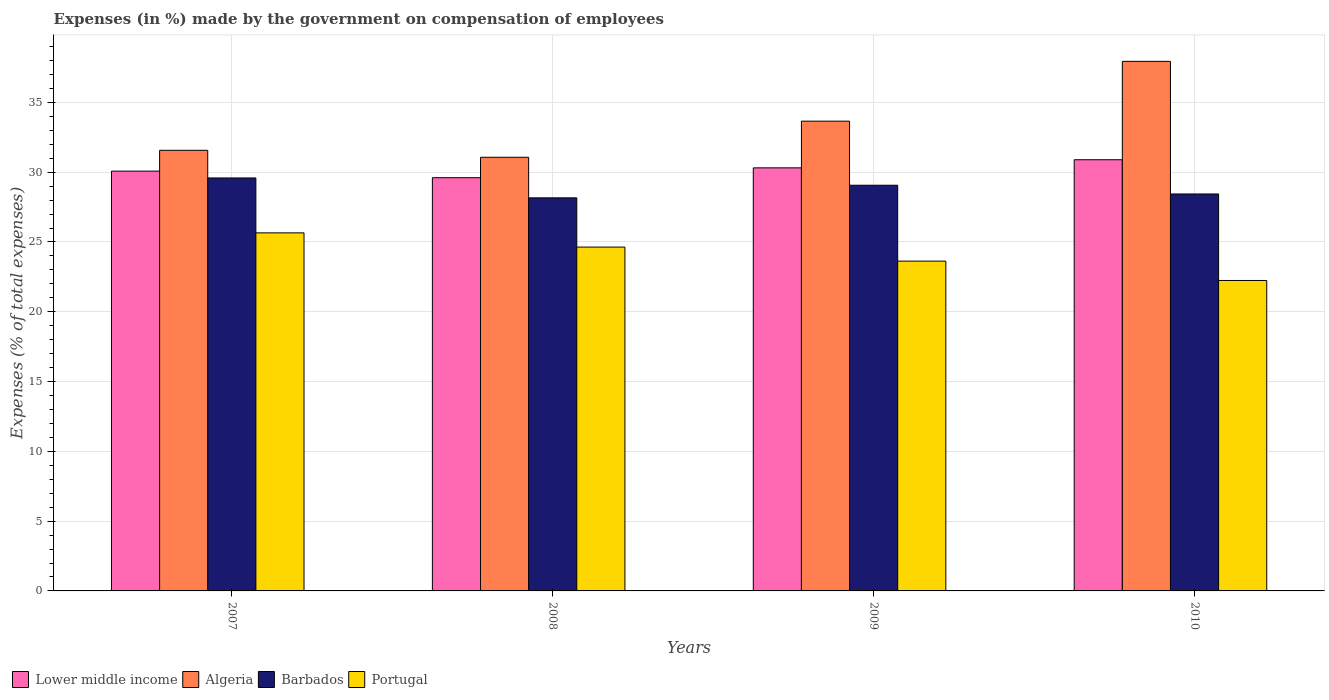Are the number of bars per tick equal to the number of legend labels?
Offer a very short reply. Yes. How many bars are there on the 2nd tick from the right?
Give a very brief answer. 4. What is the label of the 2nd group of bars from the left?
Ensure brevity in your answer.  2008. What is the percentage of expenses made by the government on compensation of employees in Barbados in 2008?
Your answer should be very brief. 28.16. Across all years, what is the maximum percentage of expenses made by the government on compensation of employees in Lower middle income?
Give a very brief answer. 30.89. Across all years, what is the minimum percentage of expenses made by the government on compensation of employees in Lower middle income?
Give a very brief answer. 29.6. What is the total percentage of expenses made by the government on compensation of employees in Algeria in the graph?
Your answer should be compact. 134.23. What is the difference between the percentage of expenses made by the government on compensation of employees in Lower middle income in 2008 and that in 2010?
Offer a very short reply. -1.29. What is the difference between the percentage of expenses made by the government on compensation of employees in Algeria in 2010 and the percentage of expenses made by the government on compensation of employees in Lower middle income in 2009?
Provide a succinct answer. 7.63. What is the average percentage of expenses made by the government on compensation of employees in Lower middle income per year?
Provide a succinct answer. 30.22. In the year 2007, what is the difference between the percentage of expenses made by the government on compensation of employees in Barbados and percentage of expenses made by the government on compensation of employees in Lower middle income?
Your response must be concise. -0.49. In how many years, is the percentage of expenses made by the government on compensation of employees in Algeria greater than 36 %?
Keep it short and to the point. 1. What is the ratio of the percentage of expenses made by the government on compensation of employees in Portugal in 2008 to that in 2009?
Keep it short and to the point. 1.04. Is the difference between the percentage of expenses made by the government on compensation of employees in Barbados in 2007 and 2010 greater than the difference between the percentage of expenses made by the government on compensation of employees in Lower middle income in 2007 and 2010?
Offer a terse response. Yes. What is the difference between the highest and the second highest percentage of expenses made by the government on compensation of employees in Algeria?
Your answer should be very brief. 4.28. What is the difference between the highest and the lowest percentage of expenses made by the government on compensation of employees in Lower middle income?
Offer a very short reply. 1.29. Is it the case that in every year, the sum of the percentage of expenses made by the government on compensation of employees in Algeria and percentage of expenses made by the government on compensation of employees in Lower middle income is greater than the sum of percentage of expenses made by the government on compensation of employees in Portugal and percentage of expenses made by the government on compensation of employees in Barbados?
Your answer should be very brief. No. What does the 3rd bar from the left in 2007 represents?
Offer a terse response. Barbados. What does the 2nd bar from the right in 2007 represents?
Your answer should be compact. Barbados. Are all the bars in the graph horizontal?
Make the answer very short. No. How many years are there in the graph?
Provide a short and direct response. 4. What is the difference between two consecutive major ticks on the Y-axis?
Your response must be concise. 5. Are the values on the major ticks of Y-axis written in scientific E-notation?
Your answer should be compact. No. Where does the legend appear in the graph?
Provide a short and direct response. Bottom left. How many legend labels are there?
Provide a succinct answer. 4. What is the title of the graph?
Offer a very short reply. Expenses (in %) made by the government on compensation of employees. What is the label or title of the Y-axis?
Your response must be concise. Expenses (% of total expenses). What is the Expenses (% of total expenses) in Lower middle income in 2007?
Ensure brevity in your answer.  30.08. What is the Expenses (% of total expenses) of Algeria in 2007?
Your answer should be very brief. 31.57. What is the Expenses (% of total expenses) in Barbados in 2007?
Keep it short and to the point. 29.59. What is the Expenses (% of total expenses) of Portugal in 2007?
Your answer should be compact. 25.65. What is the Expenses (% of total expenses) in Lower middle income in 2008?
Offer a very short reply. 29.6. What is the Expenses (% of total expenses) in Algeria in 2008?
Give a very brief answer. 31.07. What is the Expenses (% of total expenses) in Barbados in 2008?
Your answer should be compact. 28.16. What is the Expenses (% of total expenses) in Portugal in 2008?
Provide a succinct answer. 24.63. What is the Expenses (% of total expenses) of Lower middle income in 2009?
Keep it short and to the point. 30.31. What is the Expenses (% of total expenses) in Algeria in 2009?
Offer a terse response. 33.66. What is the Expenses (% of total expenses) of Barbados in 2009?
Provide a short and direct response. 29.06. What is the Expenses (% of total expenses) in Portugal in 2009?
Your answer should be compact. 23.63. What is the Expenses (% of total expenses) in Lower middle income in 2010?
Provide a short and direct response. 30.89. What is the Expenses (% of total expenses) of Algeria in 2010?
Your answer should be compact. 37.94. What is the Expenses (% of total expenses) of Barbados in 2010?
Keep it short and to the point. 28.44. What is the Expenses (% of total expenses) of Portugal in 2010?
Offer a very short reply. 22.24. Across all years, what is the maximum Expenses (% of total expenses) of Lower middle income?
Keep it short and to the point. 30.89. Across all years, what is the maximum Expenses (% of total expenses) of Algeria?
Provide a short and direct response. 37.94. Across all years, what is the maximum Expenses (% of total expenses) in Barbados?
Make the answer very short. 29.59. Across all years, what is the maximum Expenses (% of total expenses) of Portugal?
Give a very brief answer. 25.65. Across all years, what is the minimum Expenses (% of total expenses) of Lower middle income?
Your answer should be compact. 29.6. Across all years, what is the minimum Expenses (% of total expenses) of Algeria?
Make the answer very short. 31.07. Across all years, what is the minimum Expenses (% of total expenses) in Barbados?
Give a very brief answer. 28.16. Across all years, what is the minimum Expenses (% of total expenses) in Portugal?
Keep it short and to the point. 22.24. What is the total Expenses (% of total expenses) of Lower middle income in the graph?
Provide a short and direct response. 120.88. What is the total Expenses (% of total expenses) of Algeria in the graph?
Make the answer very short. 134.23. What is the total Expenses (% of total expenses) of Barbados in the graph?
Keep it short and to the point. 115.25. What is the total Expenses (% of total expenses) in Portugal in the graph?
Your answer should be very brief. 96.15. What is the difference between the Expenses (% of total expenses) of Lower middle income in 2007 and that in 2008?
Keep it short and to the point. 0.47. What is the difference between the Expenses (% of total expenses) of Algeria in 2007 and that in 2008?
Provide a succinct answer. 0.5. What is the difference between the Expenses (% of total expenses) of Barbados in 2007 and that in 2008?
Provide a succinct answer. 1.43. What is the difference between the Expenses (% of total expenses) of Portugal in 2007 and that in 2008?
Make the answer very short. 1.02. What is the difference between the Expenses (% of total expenses) in Lower middle income in 2007 and that in 2009?
Provide a short and direct response. -0.23. What is the difference between the Expenses (% of total expenses) of Algeria in 2007 and that in 2009?
Your answer should be compact. -2.09. What is the difference between the Expenses (% of total expenses) of Barbados in 2007 and that in 2009?
Provide a succinct answer. 0.52. What is the difference between the Expenses (% of total expenses) of Portugal in 2007 and that in 2009?
Make the answer very short. 2.02. What is the difference between the Expenses (% of total expenses) in Lower middle income in 2007 and that in 2010?
Offer a very short reply. -0.82. What is the difference between the Expenses (% of total expenses) of Algeria in 2007 and that in 2010?
Provide a succinct answer. -6.37. What is the difference between the Expenses (% of total expenses) of Barbados in 2007 and that in 2010?
Provide a succinct answer. 1.15. What is the difference between the Expenses (% of total expenses) of Portugal in 2007 and that in 2010?
Your answer should be compact. 3.41. What is the difference between the Expenses (% of total expenses) in Lower middle income in 2008 and that in 2009?
Your answer should be compact. -0.71. What is the difference between the Expenses (% of total expenses) in Algeria in 2008 and that in 2009?
Make the answer very short. -2.59. What is the difference between the Expenses (% of total expenses) of Barbados in 2008 and that in 2009?
Make the answer very short. -0.9. What is the difference between the Expenses (% of total expenses) of Portugal in 2008 and that in 2009?
Your response must be concise. 1. What is the difference between the Expenses (% of total expenses) of Lower middle income in 2008 and that in 2010?
Give a very brief answer. -1.29. What is the difference between the Expenses (% of total expenses) in Algeria in 2008 and that in 2010?
Your response must be concise. -6.87. What is the difference between the Expenses (% of total expenses) in Barbados in 2008 and that in 2010?
Offer a terse response. -0.28. What is the difference between the Expenses (% of total expenses) of Portugal in 2008 and that in 2010?
Offer a terse response. 2.39. What is the difference between the Expenses (% of total expenses) in Lower middle income in 2009 and that in 2010?
Give a very brief answer. -0.58. What is the difference between the Expenses (% of total expenses) in Algeria in 2009 and that in 2010?
Your answer should be very brief. -4.28. What is the difference between the Expenses (% of total expenses) in Barbados in 2009 and that in 2010?
Your response must be concise. 0.63. What is the difference between the Expenses (% of total expenses) of Portugal in 2009 and that in 2010?
Provide a short and direct response. 1.39. What is the difference between the Expenses (% of total expenses) in Lower middle income in 2007 and the Expenses (% of total expenses) in Algeria in 2008?
Your answer should be compact. -0.99. What is the difference between the Expenses (% of total expenses) in Lower middle income in 2007 and the Expenses (% of total expenses) in Barbados in 2008?
Ensure brevity in your answer.  1.92. What is the difference between the Expenses (% of total expenses) of Lower middle income in 2007 and the Expenses (% of total expenses) of Portugal in 2008?
Keep it short and to the point. 5.44. What is the difference between the Expenses (% of total expenses) in Algeria in 2007 and the Expenses (% of total expenses) in Barbados in 2008?
Make the answer very short. 3.41. What is the difference between the Expenses (% of total expenses) in Algeria in 2007 and the Expenses (% of total expenses) in Portugal in 2008?
Keep it short and to the point. 6.93. What is the difference between the Expenses (% of total expenses) of Barbados in 2007 and the Expenses (% of total expenses) of Portugal in 2008?
Your answer should be very brief. 4.95. What is the difference between the Expenses (% of total expenses) in Lower middle income in 2007 and the Expenses (% of total expenses) in Algeria in 2009?
Your answer should be compact. -3.58. What is the difference between the Expenses (% of total expenses) in Lower middle income in 2007 and the Expenses (% of total expenses) in Barbados in 2009?
Offer a terse response. 1.01. What is the difference between the Expenses (% of total expenses) in Lower middle income in 2007 and the Expenses (% of total expenses) in Portugal in 2009?
Provide a succinct answer. 6.45. What is the difference between the Expenses (% of total expenses) of Algeria in 2007 and the Expenses (% of total expenses) of Barbados in 2009?
Ensure brevity in your answer.  2.5. What is the difference between the Expenses (% of total expenses) of Algeria in 2007 and the Expenses (% of total expenses) of Portugal in 2009?
Offer a very short reply. 7.94. What is the difference between the Expenses (% of total expenses) of Barbados in 2007 and the Expenses (% of total expenses) of Portugal in 2009?
Provide a succinct answer. 5.96. What is the difference between the Expenses (% of total expenses) of Lower middle income in 2007 and the Expenses (% of total expenses) of Algeria in 2010?
Give a very brief answer. -7.86. What is the difference between the Expenses (% of total expenses) in Lower middle income in 2007 and the Expenses (% of total expenses) in Barbados in 2010?
Give a very brief answer. 1.64. What is the difference between the Expenses (% of total expenses) in Lower middle income in 2007 and the Expenses (% of total expenses) in Portugal in 2010?
Your response must be concise. 7.83. What is the difference between the Expenses (% of total expenses) of Algeria in 2007 and the Expenses (% of total expenses) of Barbados in 2010?
Your answer should be very brief. 3.13. What is the difference between the Expenses (% of total expenses) of Algeria in 2007 and the Expenses (% of total expenses) of Portugal in 2010?
Your answer should be very brief. 9.33. What is the difference between the Expenses (% of total expenses) of Barbados in 2007 and the Expenses (% of total expenses) of Portugal in 2010?
Offer a very short reply. 7.34. What is the difference between the Expenses (% of total expenses) in Lower middle income in 2008 and the Expenses (% of total expenses) in Algeria in 2009?
Make the answer very short. -4.05. What is the difference between the Expenses (% of total expenses) in Lower middle income in 2008 and the Expenses (% of total expenses) in Barbados in 2009?
Keep it short and to the point. 0.54. What is the difference between the Expenses (% of total expenses) of Lower middle income in 2008 and the Expenses (% of total expenses) of Portugal in 2009?
Your answer should be very brief. 5.98. What is the difference between the Expenses (% of total expenses) of Algeria in 2008 and the Expenses (% of total expenses) of Barbados in 2009?
Make the answer very short. 2. What is the difference between the Expenses (% of total expenses) of Algeria in 2008 and the Expenses (% of total expenses) of Portugal in 2009?
Offer a terse response. 7.44. What is the difference between the Expenses (% of total expenses) in Barbados in 2008 and the Expenses (% of total expenses) in Portugal in 2009?
Your response must be concise. 4.53. What is the difference between the Expenses (% of total expenses) in Lower middle income in 2008 and the Expenses (% of total expenses) in Algeria in 2010?
Your answer should be compact. -8.34. What is the difference between the Expenses (% of total expenses) in Lower middle income in 2008 and the Expenses (% of total expenses) in Barbados in 2010?
Give a very brief answer. 1.17. What is the difference between the Expenses (% of total expenses) of Lower middle income in 2008 and the Expenses (% of total expenses) of Portugal in 2010?
Offer a very short reply. 7.36. What is the difference between the Expenses (% of total expenses) of Algeria in 2008 and the Expenses (% of total expenses) of Barbados in 2010?
Your response must be concise. 2.63. What is the difference between the Expenses (% of total expenses) in Algeria in 2008 and the Expenses (% of total expenses) in Portugal in 2010?
Make the answer very short. 8.83. What is the difference between the Expenses (% of total expenses) of Barbados in 2008 and the Expenses (% of total expenses) of Portugal in 2010?
Offer a terse response. 5.92. What is the difference between the Expenses (% of total expenses) of Lower middle income in 2009 and the Expenses (% of total expenses) of Algeria in 2010?
Offer a very short reply. -7.63. What is the difference between the Expenses (% of total expenses) in Lower middle income in 2009 and the Expenses (% of total expenses) in Barbados in 2010?
Make the answer very short. 1.87. What is the difference between the Expenses (% of total expenses) in Lower middle income in 2009 and the Expenses (% of total expenses) in Portugal in 2010?
Give a very brief answer. 8.07. What is the difference between the Expenses (% of total expenses) of Algeria in 2009 and the Expenses (% of total expenses) of Barbados in 2010?
Your answer should be compact. 5.22. What is the difference between the Expenses (% of total expenses) in Algeria in 2009 and the Expenses (% of total expenses) in Portugal in 2010?
Offer a very short reply. 11.41. What is the difference between the Expenses (% of total expenses) in Barbados in 2009 and the Expenses (% of total expenses) in Portugal in 2010?
Give a very brief answer. 6.82. What is the average Expenses (% of total expenses) in Lower middle income per year?
Ensure brevity in your answer.  30.22. What is the average Expenses (% of total expenses) in Algeria per year?
Your answer should be compact. 33.56. What is the average Expenses (% of total expenses) in Barbados per year?
Provide a short and direct response. 28.81. What is the average Expenses (% of total expenses) in Portugal per year?
Keep it short and to the point. 24.04. In the year 2007, what is the difference between the Expenses (% of total expenses) in Lower middle income and Expenses (% of total expenses) in Algeria?
Offer a very short reply. -1.49. In the year 2007, what is the difference between the Expenses (% of total expenses) in Lower middle income and Expenses (% of total expenses) in Barbados?
Your answer should be very brief. 0.49. In the year 2007, what is the difference between the Expenses (% of total expenses) of Lower middle income and Expenses (% of total expenses) of Portugal?
Your answer should be compact. 4.42. In the year 2007, what is the difference between the Expenses (% of total expenses) of Algeria and Expenses (% of total expenses) of Barbados?
Provide a short and direct response. 1.98. In the year 2007, what is the difference between the Expenses (% of total expenses) in Algeria and Expenses (% of total expenses) in Portugal?
Give a very brief answer. 5.91. In the year 2007, what is the difference between the Expenses (% of total expenses) in Barbados and Expenses (% of total expenses) in Portugal?
Give a very brief answer. 3.93. In the year 2008, what is the difference between the Expenses (% of total expenses) in Lower middle income and Expenses (% of total expenses) in Algeria?
Provide a short and direct response. -1.46. In the year 2008, what is the difference between the Expenses (% of total expenses) of Lower middle income and Expenses (% of total expenses) of Barbados?
Provide a succinct answer. 1.44. In the year 2008, what is the difference between the Expenses (% of total expenses) of Lower middle income and Expenses (% of total expenses) of Portugal?
Make the answer very short. 4.97. In the year 2008, what is the difference between the Expenses (% of total expenses) of Algeria and Expenses (% of total expenses) of Barbados?
Keep it short and to the point. 2.91. In the year 2008, what is the difference between the Expenses (% of total expenses) in Algeria and Expenses (% of total expenses) in Portugal?
Offer a terse response. 6.43. In the year 2008, what is the difference between the Expenses (% of total expenses) of Barbados and Expenses (% of total expenses) of Portugal?
Your response must be concise. 3.53. In the year 2009, what is the difference between the Expenses (% of total expenses) in Lower middle income and Expenses (% of total expenses) in Algeria?
Provide a short and direct response. -3.35. In the year 2009, what is the difference between the Expenses (% of total expenses) in Lower middle income and Expenses (% of total expenses) in Barbados?
Keep it short and to the point. 1.25. In the year 2009, what is the difference between the Expenses (% of total expenses) of Lower middle income and Expenses (% of total expenses) of Portugal?
Offer a very short reply. 6.68. In the year 2009, what is the difference between the Expenses (% of total expenses) of Algeria and Expenses (% of total expenses) of Barbados?
Keep it short and to the point. 4.59. In the year 2009, what is the difference between the Expenses (% of total expenses) of Algeria and Expenses (% of total expenses) of Portugal?
Make the answer very short. 10.03. In the year 2009, what is the difference between the Expenses (% of total expenses) of Barbados and Expenses (% of total expenses) of Portugal?
Your answer should be compact. 5.44. In the year 2010, what is the difference between the Expenses (% of total expenses) in Lower middle income and Expenses (% of total expenses) in Algeria?
Ensure brevity in your answer.  -7.05. In the year 2010, what is the difference between the Expenses (% of total expenses) in Lower middle income and Expenses (% of total expenses) in Barbados?
Offer a very short reply. 2.45. In the year 2010, what is the difference between the Expenses (% of total expenses) of Lower middle income and Expenses (% of total expenses) of Portugal?
Your answer should be compact. 8.65. In the year 2010, what is the difference between the Expenses (% of total expenses) of Algeria and Expenses (% of total expenses) of Barbados?
Offer a terse response. 9.5. In the year 2010, what is the difference between the Expenses (% of total expenses) in Algeria and Expenses (% of total expenses) in Portugal?
Offer a very short reply. 15.7. In the year 2010, what is the difference between the Expenses (% of total expenses) in Barbados and Expenses (% of total expenses) in Portugal?
Offer a very short reply. 6.2. What is the ratio of the Expenses (% of total expenses) of Lower middle income in 2007 to that in 2008?
Your answer should be very brief. 1.02. What is the ratio of the Expenses (% of total expenses) of Algeria in 2007 to that in 2008?
Offer a very short reply. 1.02. What is the ratio of the Expenses (% of total expenses) in Barbados in 2007 to that in 2008?
Make the answer very short. 1.05. What is the ratio of the Expenses (% of total expenses) of Portugal in 2007 to that in 2008?
Keep it short and to the point. 1.04. What is the ratio of the Expenses (% of total expenses) in Lower middle income in 2007 to that in 2009?
Offer a very short reply. 0.99. What is the ratio of the Expenses (% of total expenses) of Algeria in 2007 to that in 2009?
Make the answer very short. 0.94. What is the ratio of the Expenses (% of total expenses) of Barbados in 2007 to that in 2009?
Keep it short and to the point. 1.02. What is the ratio of the Expenses (% of total expenses) of Portugal in 2007 to that in 2009?
Provide a succinct answer. 1.09. What is the ratio of the Expenses (% of total expenses) in Lower middle income in 2007 to that in 2010?
Offer a very short reply. 0.97. What is the ratio of the Expenses (% of total expenses) of Algeria in 2007 to that in 2010?
Give a very brief answer. 0.83. What is the ratio of the Expenses (% of total expenses) of Barbados in 2007 to that in 2010?
Your answer should be compact. 1.04. What is the ratio of the Expenses (% of total expenses) of Portugal in 2007 to that in 2010?
Keep it short and to the point. 1.15. What is the ratio of the Expenses (% of total expenses) of Lower middle income in 2008 to that in 2009?
Provide a succinct answer. 0.98. What is the ratio of the Expenses (% of total expenses) of Algeria in 2008 to that in 2009?
Your answer should be compact. 0.92. What is the ratio of the Expenses (% of total expenses) of Barbados in 2008 to that in 2009?
Your response must be concise. 0.97. What is the ratio of the Expenses (% of total expenses) in Portugal in 2008 to that in 2009?
Your answer should be very brief. 1.04. What is the ratio of the Expenses (% of total expenses) in Lower middle income in 2008 to that in 2010?
Your answer should be very brief. 0.96. What is the ratio of the Expenses (% of total expenses) in Algeria in 2008 to that in 2010?
Your answer should be compact. 0.82. What is the ratio of the Expenses (% of total expenses) of Barbados in 2008 to that in 2010?
Your answer should be compact. 0.99. What is the ratio of the Expenses (% of total expenses) in Portugal in 2008 to that in 2010?
Your response must be concise. 1.11. What is the ratio of the Expenses (% of total expenses) of Lower middle income in 2009 to that in 2010?
Your answer should be compact. 0.98. What is the ratio of the Expenses (% of total expenses) in Algeria in 2009 to that in 2010?
Your answer should be compact. 0.89. What is the ratio of the Expenses (% of total expenses) of Portugal in 2009 to that in 2010?
Your answer should be compact. 1.06. What is the difference between the highest and the second highest Expenses (% of total expenses) in Lower middle income?
Keep it short and to the point. 0.58. What is the difference between the highest and the second highest Expenses (% of total expenses) in Algeria?
Offer a terse response. 4.28. What is the difference between the highest and the second highest Expenses (% of total expenses) in Barbados?
Provide a short and direct response. 0.52. What is the difference between the highest and the second highest Expenses (% of total expenses) of Portugal?
Give a very brief answer. 1.02. What is the difference between the highest and the lowest Expenses (% of total expenses) in Lower middle income?
Keep it short and to the point. 1.29. What is the difference between the highest and the lowest Expenses (% of total expenses) of Algeria?
Ensure brevity in your answer.  6.87. What is the difference between the highest and the lowest Expenses (% of total expenses) in Barbados?
Provide a short and direct response. 1.43. What is the difference between the highest and the lowest Expenses (% of total expenses) of Portugal?
Offer a terse response. 3.41. 